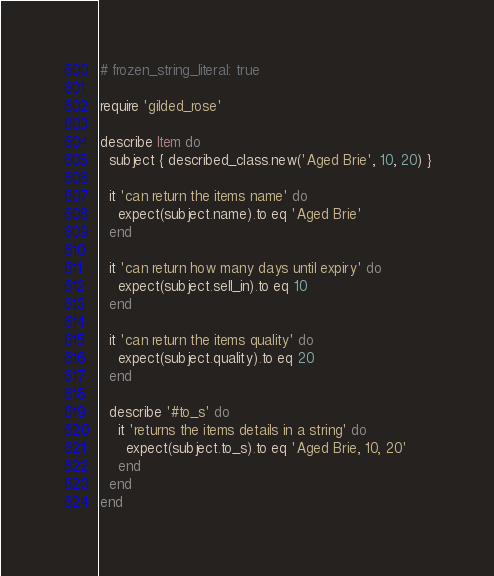<code> <loc_0><loc_0><loc_500><loc_500><_Ruby_># frozen_string_literal: true

require 'gilded_rose'

describe Item do
  subject { described_class.new('Aged Brie', 10, 20) }

  it 'can return the items name' do
    expect(subject.name).to eq 'Aged Brie'
  end

  it 'can return how many days until expiry' do
    expect(subject.sell_in).to eq 10
  end

  it 'can return the items quality' do
    expect(subject.quality).to eq 20
  end

  describe '#to_s' do
    it 'returns the items details in a string' do
      expect(subject.to_s).to eq 'Aged Brie, 10, 20'
    end
  end
end
</code> 